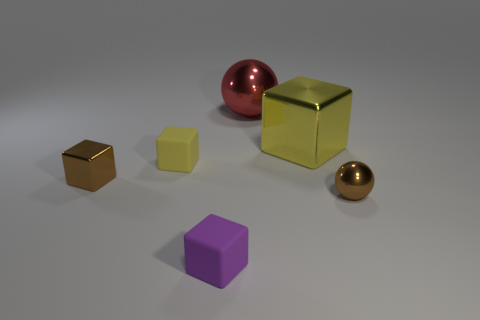Add 4 tiny blue cubes. How many objects exist? 10 Subtract all cubes. How many objects are left? 2 Add 5 tiny brown metallic balls. How many tiny brown metallic balls are left? 6 Add 2 small brown blocks. How many small brown blocks exist? 3 Subtract 0 blue cylinders. How many objects are left? 6 Subtract all tiny brown metallic blocks. Subtract all brown metallic balls. How many objects are left? 4 